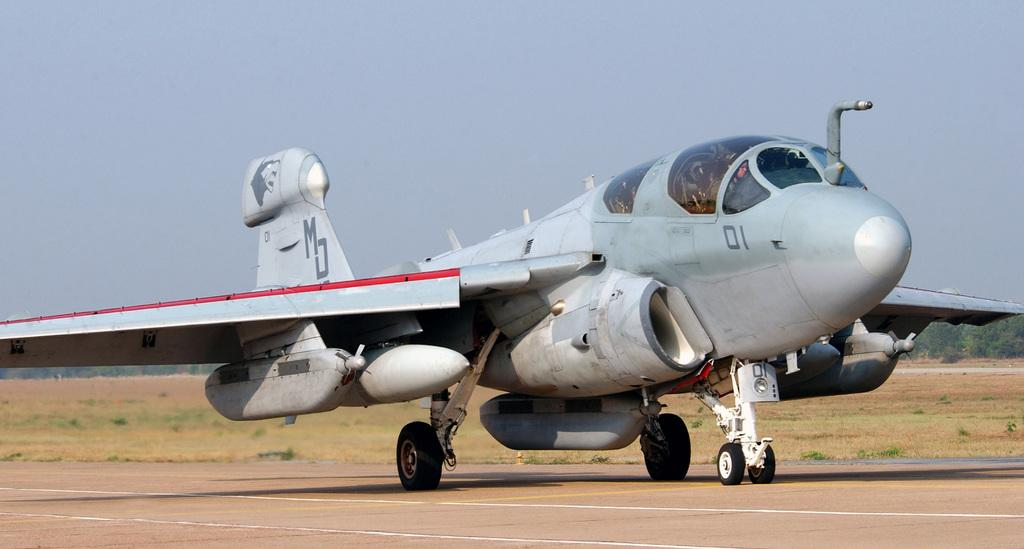What is the main color of the plain visible in the image? The plain is white in the image. What type of vegetation can be seen in the image? There is grass visible in the image. What can be seen in the background of the image? There are trees in the background of the image. What is visible at the top of the image? The sky is visible at the top of the image. What type of kettle is being used in the competition on the plain? There is no competition or kettle present in the image; it features a white plain with grass, trees, and the sky. 